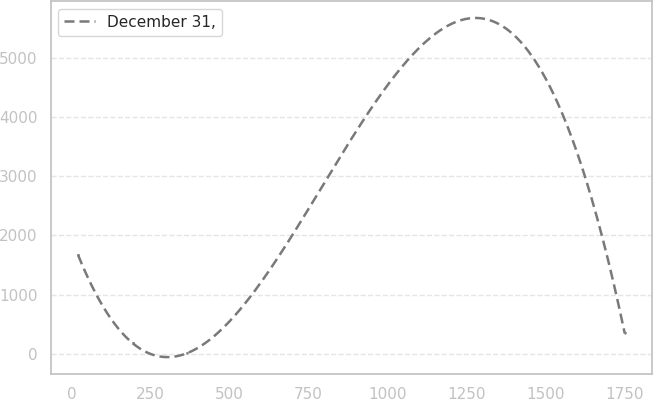Convert chart to OTSL. <chart><loc_0><loc_0><loc_500><loc_500><line_chart><ecel><fcel>December 31,<nl><fcel>20.8<fcel>1670.66<nl><fcel>193.74<fcel>179.63<nl><fcel>366.68<fcel>13.96<nl><fcel>1750.23<fcel>345.3<nl></chart> 